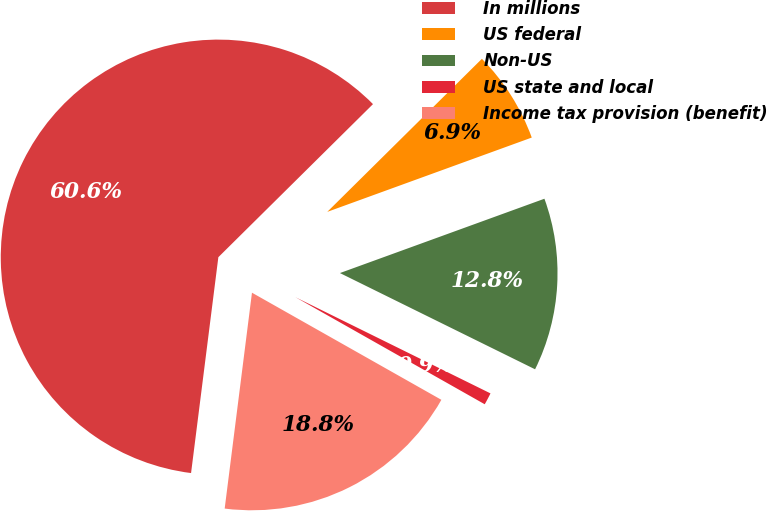Convert chart to OTSL. <chart><loc_0><loc_0><loc_500><loc_500><pie_chart><fcel>In millions<fcel>US federal<fcel>Non-US<fcel>US state and local<fcel>Income tax provision (benefit)<nl><fcel>60.58%<fcel>6.87%<fcel>12.84%<fcel>0.9%<fcel>18.81%<nl></chart> 